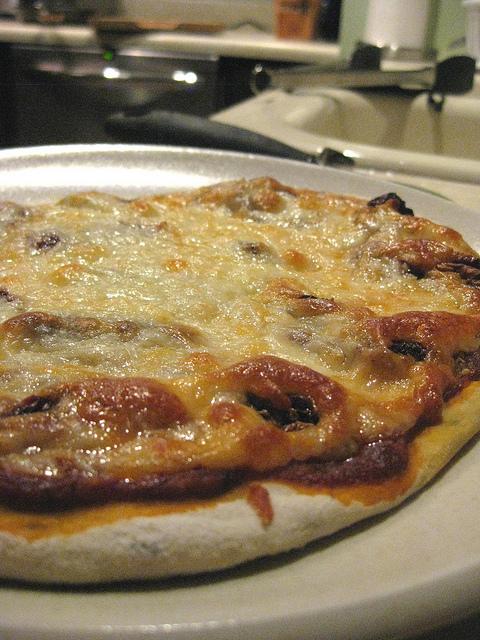Is there a sink in the picture?
Answer briefly. Yes. Is this in a restaurant?
Short answer required. No. Is the pizza burnt?
Be succinct. No. 